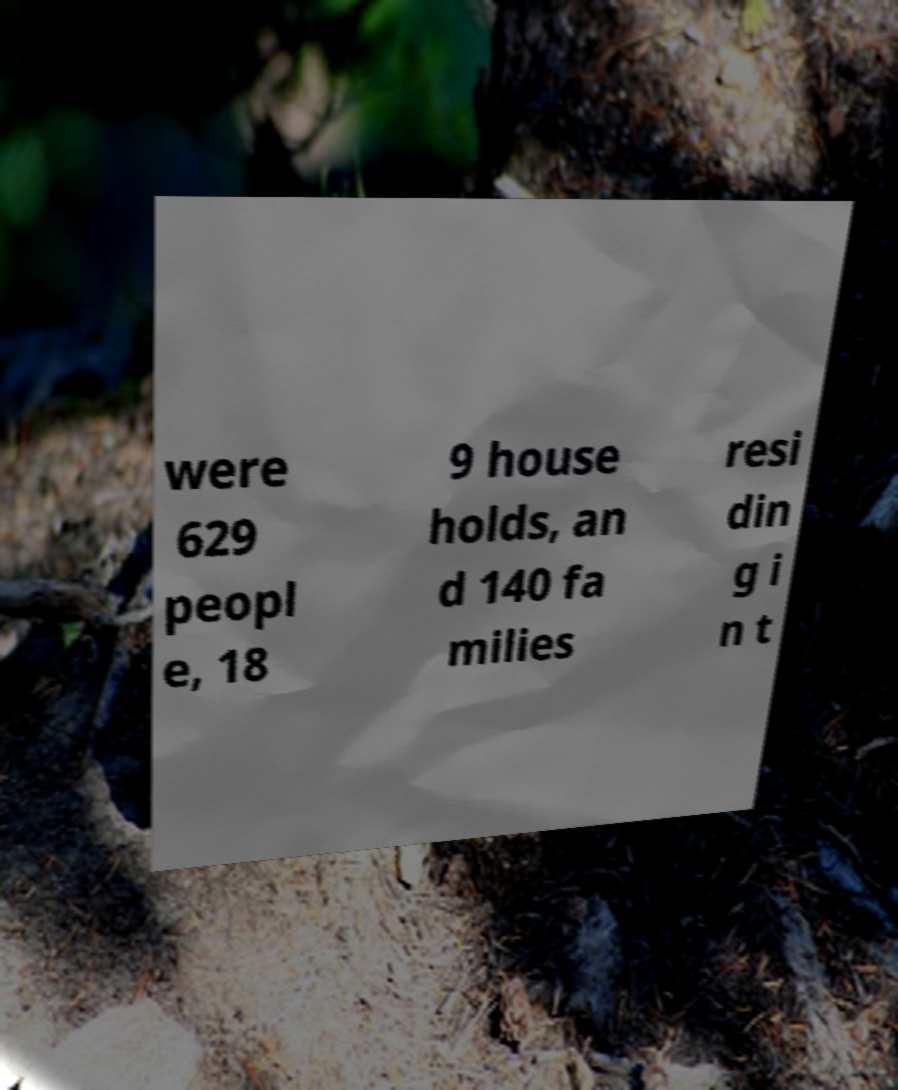What messages or text are displayed in this image? I need them in a readable, typed format. were 629 peopl e, 18 9 house holds, an d 140 fa milies resi din g i n t 